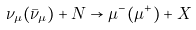Convert formula to latex. <formula><loc_0><loc_0><loc_500><loc_500>\nu _ { \mu } ( \bar { \nu } _ { \mu } ) + N \to \mu ^ { - } ( \mu ^ { + } ) + X</formula> 